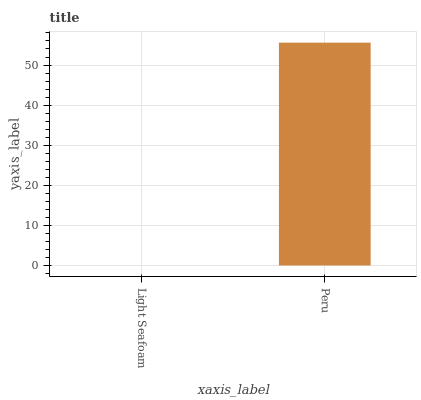Is Light Seafoam the minimum?
Answer yes or no. Yes. Is Peru the maximum?
Answer yes or no. Yes. Is Peru the minimum?
Answer yes or no. No. Is Peru greater than Light Seafoam?
Answer yes or no. Yes. Is Light Seafoam less than Peru?
Answer yes or no. Yes. Is Light Seafoam greater than Peru?
Answer yes or no. No. Is Peru less than Light Seafoam?
Answer yes or no. No. Is Peru the high median?
Answer yes or no. Yes. Is Light Seafoam the low median?
Answer yes or no. Yes. Is Light Seafoam the high median?
Answer yes or no. No. Is Peru the low median?
Answer yes or no. No. 